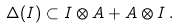Convert formula to latex. <formula><loc_0><loc_0><loc_500><loc_500>\Delta ( I ) \subset I \otimes A + A \otimes I \, .</formula> 